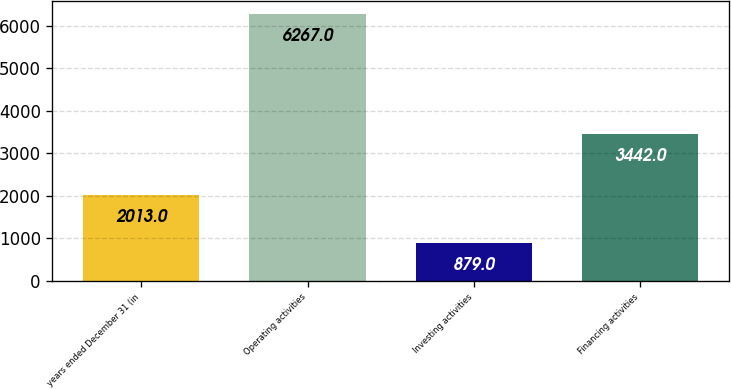Convert chart. <chart><loc_0><loc_0><loc_500><loc_500><bar_chart><fcel>years ended December 31 (in<fcel>Operating activities<fcel>Investing activities<fcel>Financing activities<nl><fcel>2013<fcel>6267<fcel>879<fcel>3442<nl></chart> 